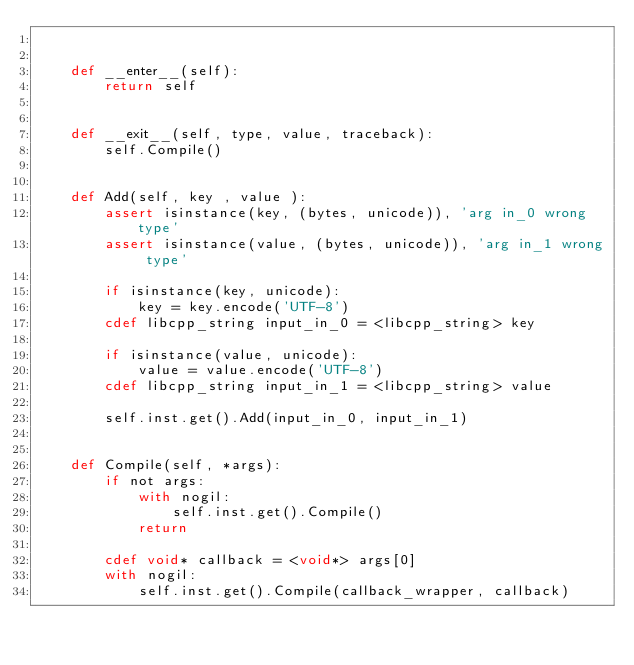Convert code to text. <code><loc_0><loc_0><loc_500><loc_500><_Cython_>

    def __enter__(self):
        return self

    
    def __exit__(self, type, value, traceback):
        self.Compile()


    def Add(self, key , value ):
        assert isinstance(key, (bytes, unicode)), 'arg in_0 wrong type'
        assert isinstance(value, (bytes, unicode)), 'arg in_1 wrong type'

        if isinstance(key, unicode):
            key = key.encode('UTF-8')
        cdef libcpp_string input_in_0 = <libcpp_string> key

        if isinstance(value, unicode):
            value = value.encode('UTF-8')
        cdef libcpp_string input_in_1 = <libcpp_string> value

        self.inst.get().Add(input_in_0, input_in_1)

        
    def Compile(self, *args):
        if not args:
            with nogil:
                self.inst.get().Compile()
            return

        cdef void* callback = <void*> args[0]
        with nogil:
            self.inst.get().Compile(callback_wrapper, callback)

</code> 